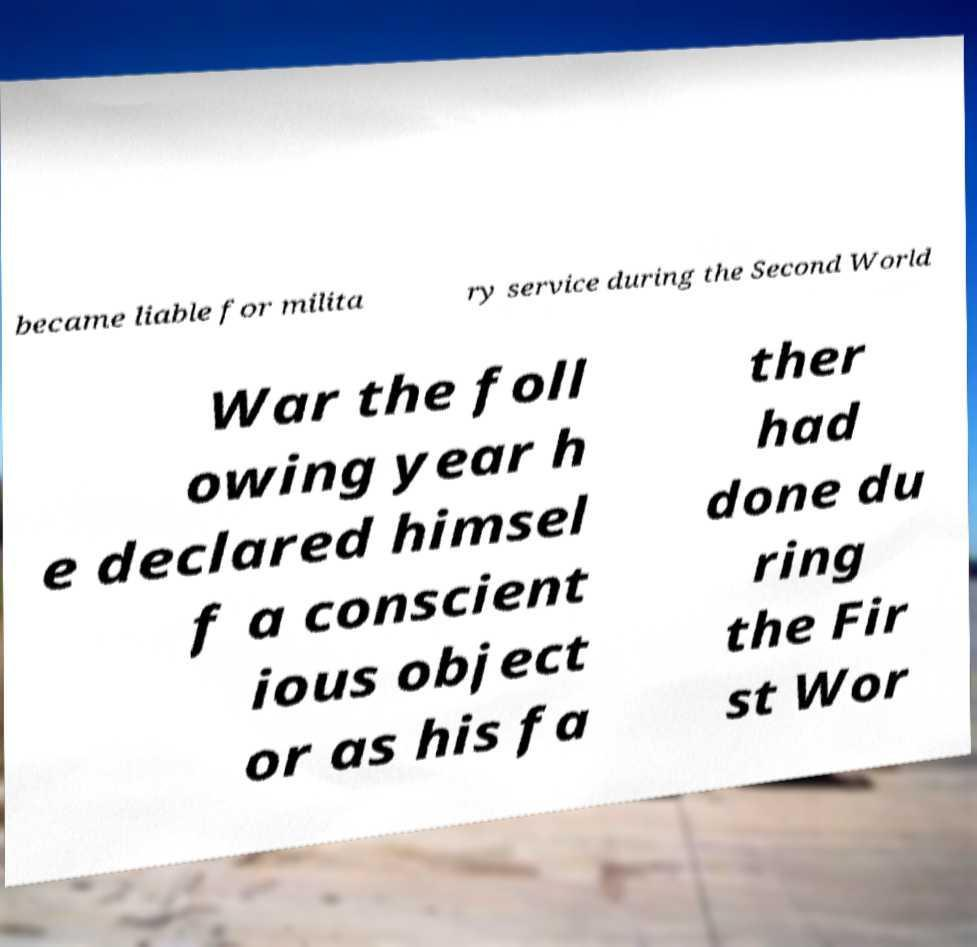Can you accurately transcribe the text from the provided image for me? became liable for milita ry service during the Second World War the foll owing year h e declared himsel f a conscient ious object or as his fa ther had done du ring the Fir st Wor 